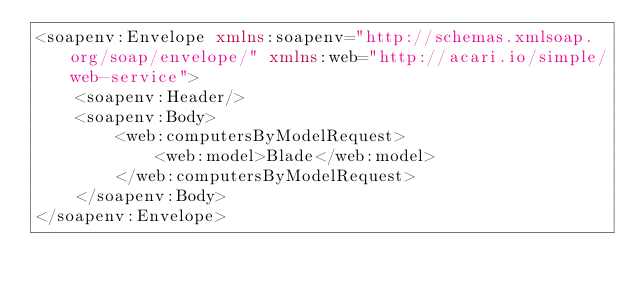<code> <loc_0><loc_0><loc_500><loc_500><_XML_><soapenv:Envelope xmlns:soapenv="http://schemas.xmlsoap.org/soap/envelope/" xmlns:web="http://acari.io/simple/web-service">
    <soapenv:Header/>
    <soapenv:Body>
        <web:computersByModelRequest>
            <web:model>Blade</web:model>
        </web:computersByModelRequest>
    </soapenv:Body>
</soapenv:Envelope></code> 